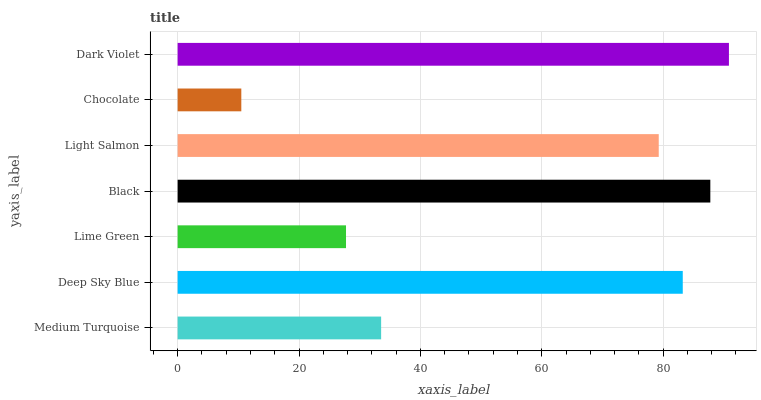Is Chocolate the minimum?
Answer yes or no. Yes. Is Dark Violet the maximum?
Answer yes or no. Yes. Is Deep Sky Blue the minimum?
Answer yes or no. No. Is Deep Sky Blue the maximum?
Answer yes or no. No. Is Deep Sky Blue greater than Medium Turquoise?
Answer yes or no. Yes. Is Medium Turquoise less than Deep Sky Blue?
Answer yes or no. Yes. Is Medium Turquoise greater than Deep Sky Blue?
Answer yes or no. No. Is Deep Sky Blue less than Medium Turquoise?
Answer yes or no. No. Is Light Salmon the high median?
Answer yes or no. Yes. Is Light Salmon the low median?
Answer yes or no. Yes. Is Dark Violet the high median?
Answer yes or no. No. Is Lime Green the low median?
Answer yes or no. No. 